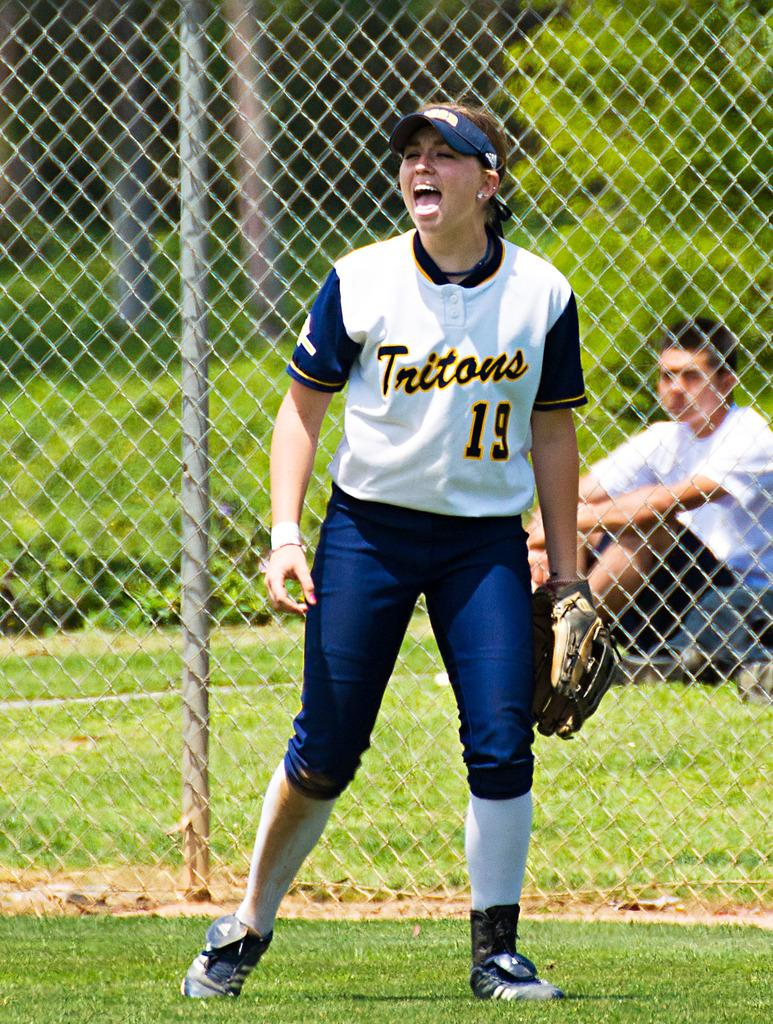<image>
Offer a succinct explanation of the picture presented. The girl shouting is wearing the number 19 top. 